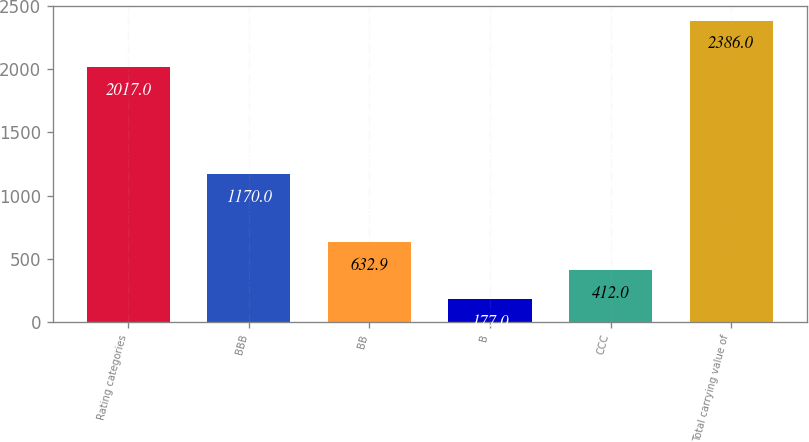Convert chart to OTSL. <chart><loc_0><loc_0><loc_500><loc_500><bar_chart><fcel>Rating categories<fcel>BBB<fcel>BB<fcel>B<fcel>CCC<fcel>Total carrying value of<nl><fcel>2017<fcel>1170<fcel>632.9<fcel>177<fcel>412<fcel>2386<nl></chart> 